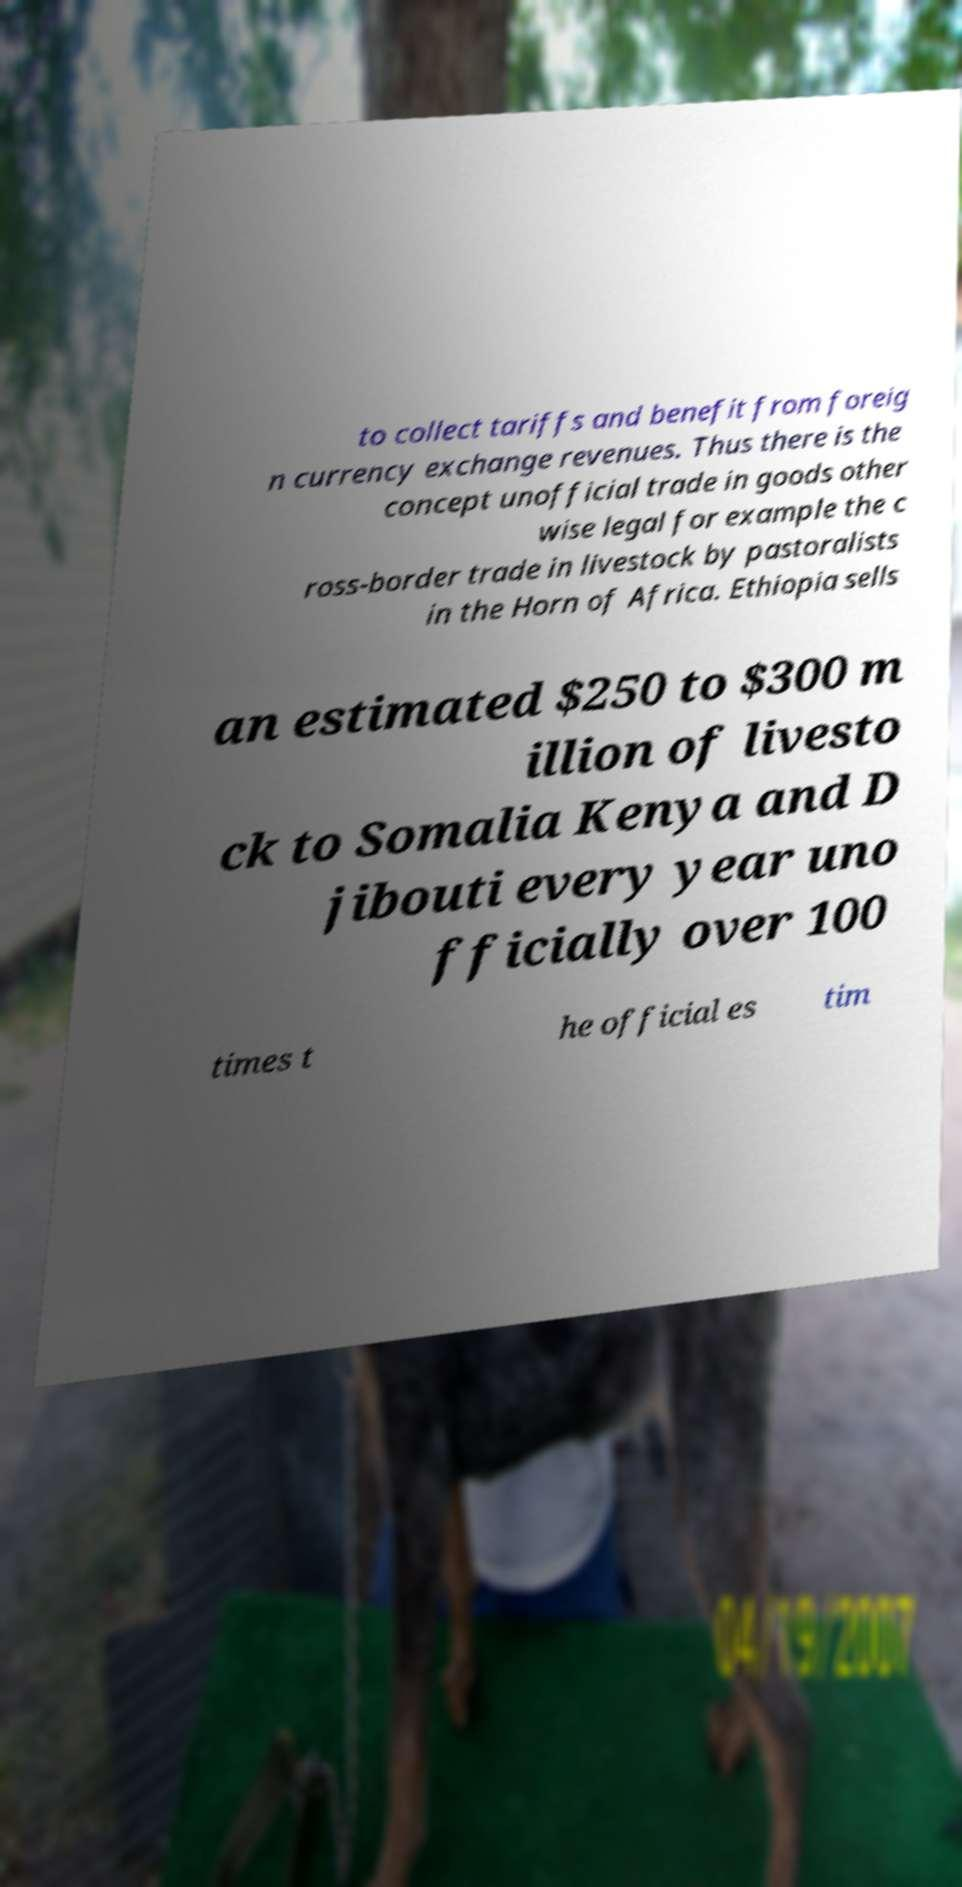Please read and relay the text visible in this image. What does it say? to collect tariffs and benefit from foreig n currency exchange revenues. Thus there is the concept unofficial trade in goods other wise legal for example the c ross-border trade in livestock by pastoralists in the Horn of Africa. Ethiopia sells an estimated $250 to $300 m illion of livesto ck to Somalia Kenya and D jibouti every year uno fficially over 100 times t he official es tim 